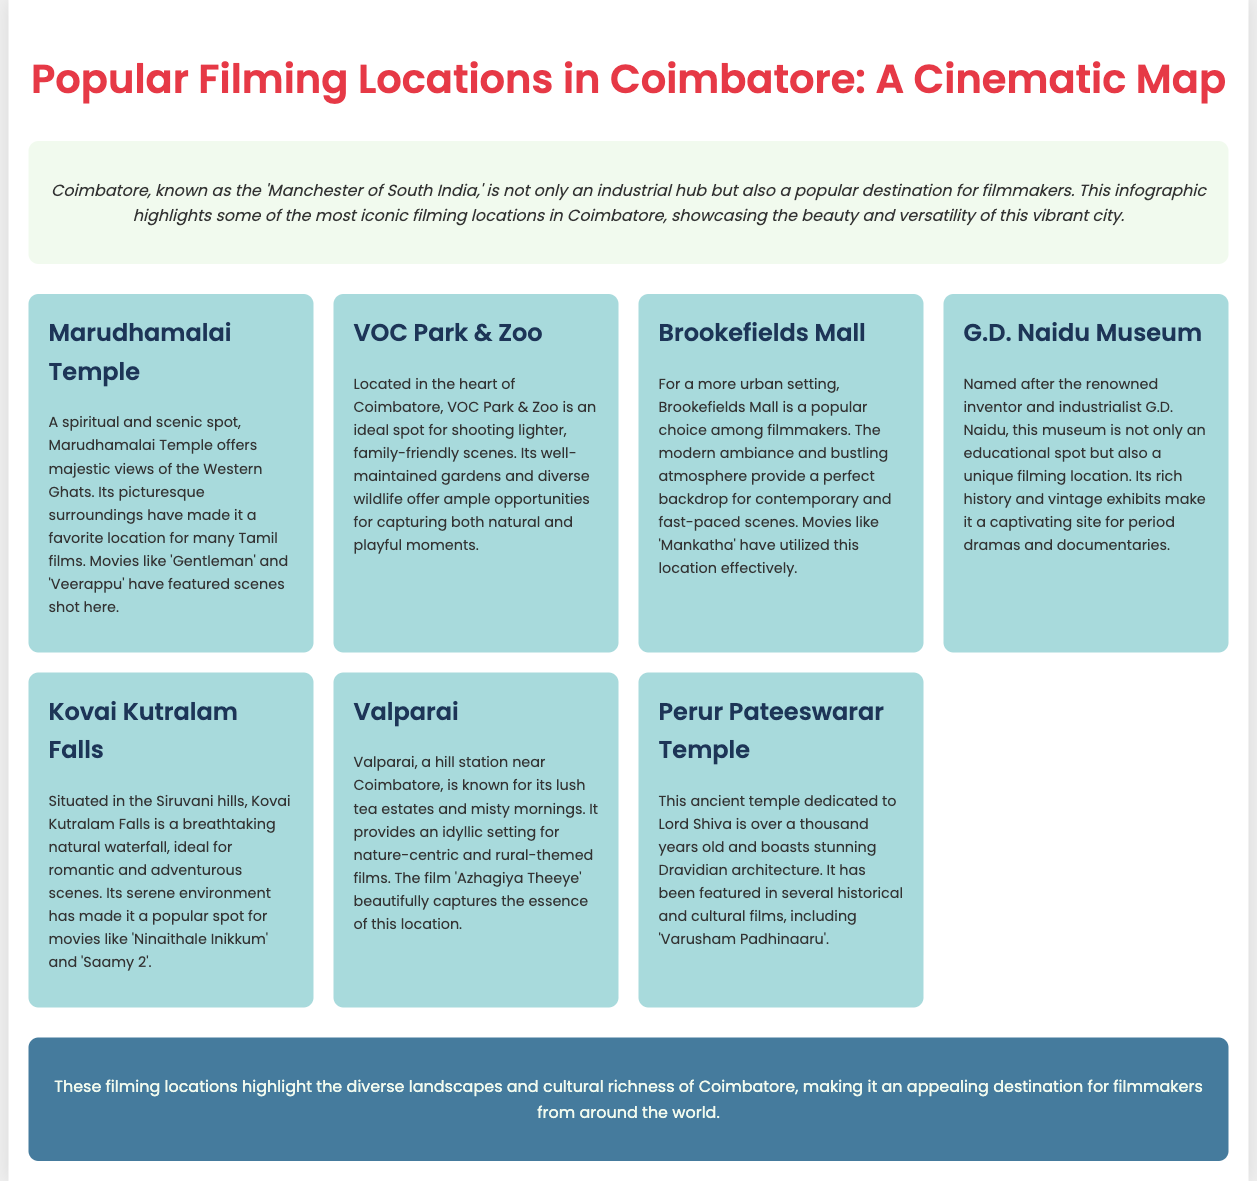what is the title of the infographic? The title of the infographic is displayed prominently at the top of the document.
Answer: Popular Filming Locations in Coimbatore: A Cinematic Map which temple is known for its majestic views of the Western Ghats? The document mentions a specific temple and highlights its scenic beauty.
Answer: Marudhamalai Temple which location is ideal for lighter, family-friendly scenes? The document specifies a location known for its gardens and wildlife, suitable for family scenes.
Answer: VOC Park & Zoo what movie features scenes shot at Brookefields Mall? The document names a specific movie that utilized this urban setting for its scenes.
Answer: Mankatha what is the significance of G.D. Naidu Museum in filmmaking? The document describes the museum's uniqueness as a filming location due to its historical significance.
Answer: Unique filming location name a movie that has scenes shot at Kovai Kutralam Falls. The document provides a couple of movies that feature this natural waterfall, indicating its cinematic use.
Answer: Ninaithale Inikkum which filming location is known for lush tea estates? The document mentions a specific hill station recognized for its tea estates.
Answer: Valparai how old is the Perur Pateeswarar Temple? The document provides information about the temple's age, which is a notable feature.
Answer: Over a thousand years old 